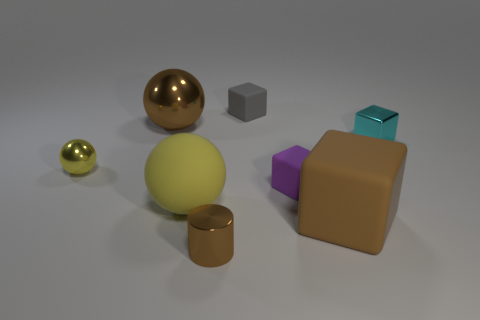Subtract 1 blocks. How many blocks are left? 3 Subtract all red blocks. Subtract all yellow cylinders. How many blocks are left? 4 Add 2 yellow rubber objects. How many objects exist? 10 Subtract all cylinders. How many objects are left? 7 Add 5 green blocks. How many green blocks exist? 5 Subtract 0 green cylinders. How many objects are left? 8 Subtract all large red matte cylinders. Subtract all yellow objects. How many objects are left? 6 Add 3 tiny spheres. How many tiny spheres are left? 4 